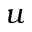<formula> <loc_0><loc_0><loc_500><loc_500>u</formula> 